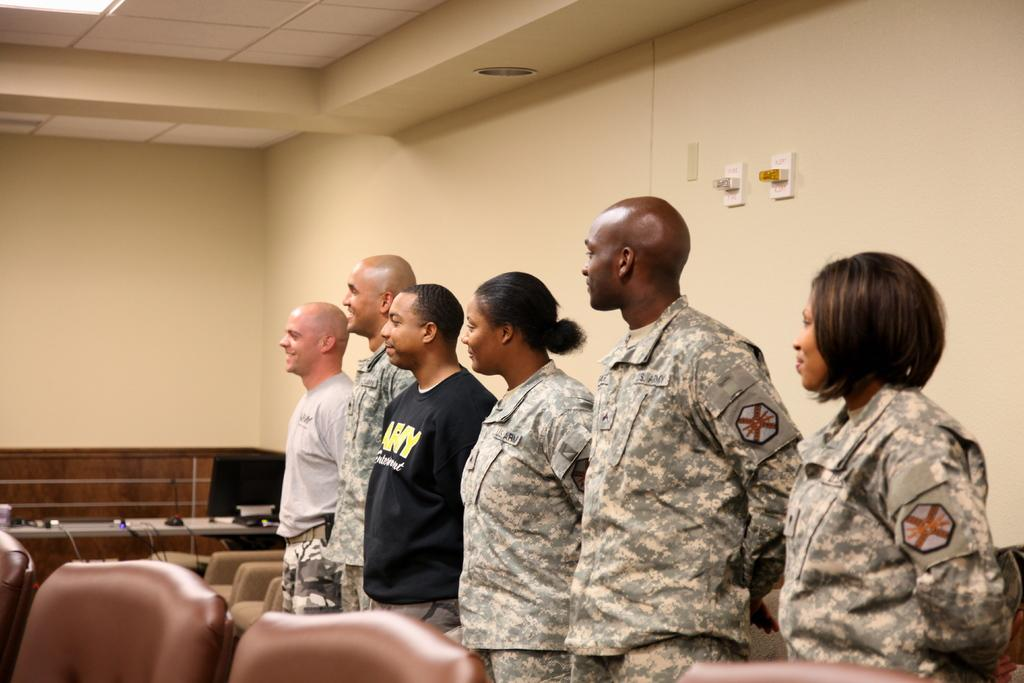How many people are in the image? There is a group of people in the image, but the exact number cannot be determined from the provided facts. What electronic device is visible in the image? There is a monitor in the image. What input device is visible in the image? There is a mouse in the image. What type of furniture is present in the image? There are tables and chairs in the image. What objects can be seen in the image? There are some objects in the image, but their specific nature cannot be determined from the provided facts. What can be seen in the background of the image? There is a wall and a roof in the background of the image. How many pies are being served by the fireman in the image? There is no fireman or pies present in the image. What type of place is depicted in the image? The provided facts do not give any information about the type of place depicted in the image. 